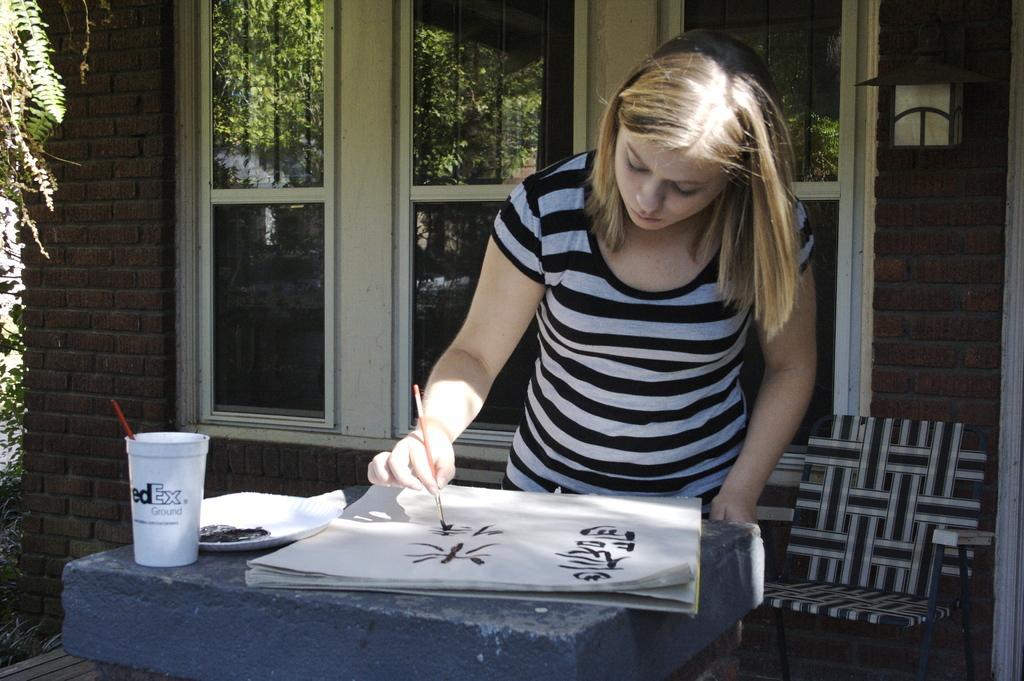Can you describe this image briefly? In the image we can see there is a woman who is writing something on paper by holding a brush behind her there is a window and there is a wall made up of red bricks and the woman is wearing a black and white t shirt. Behind her there is a chair. 